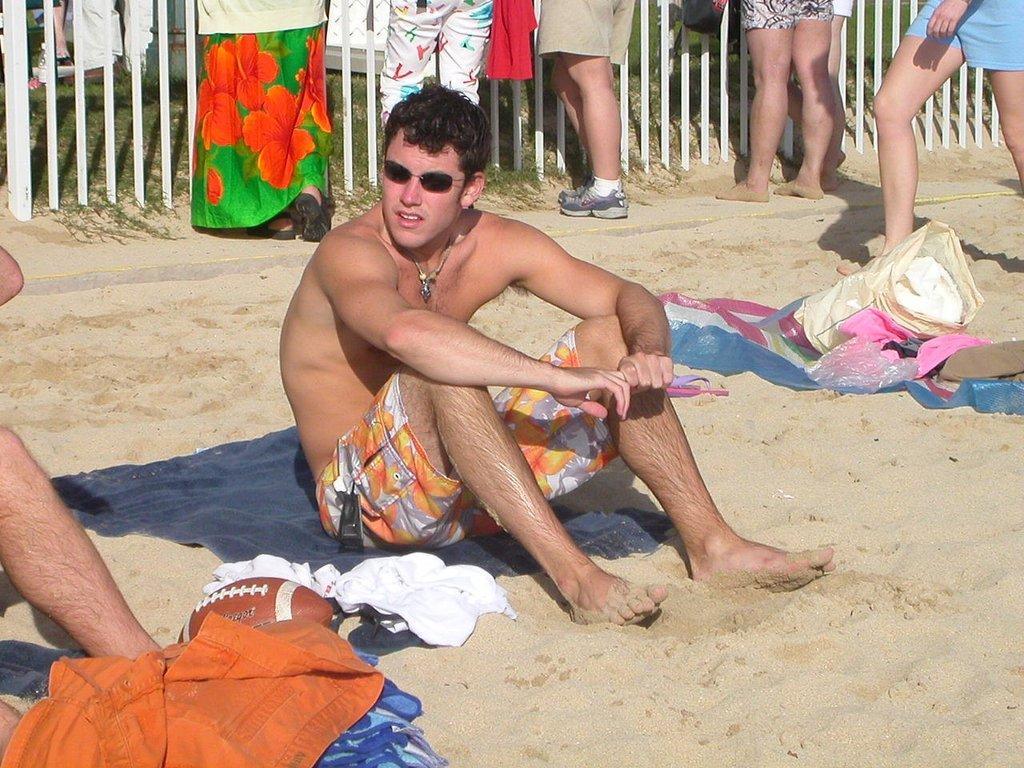Describe this image in one or two sentences. In this image we can see a man wearing sunglasses and sitting and we can see some clothes and some other objects on the sand. There are few people and we can see the railing in the background and we can see the grass on the ground. 